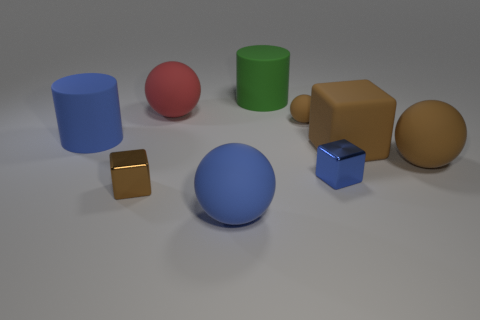There is a small matte thing that is the same shape as the big red rubber thing; what color is it? brown 